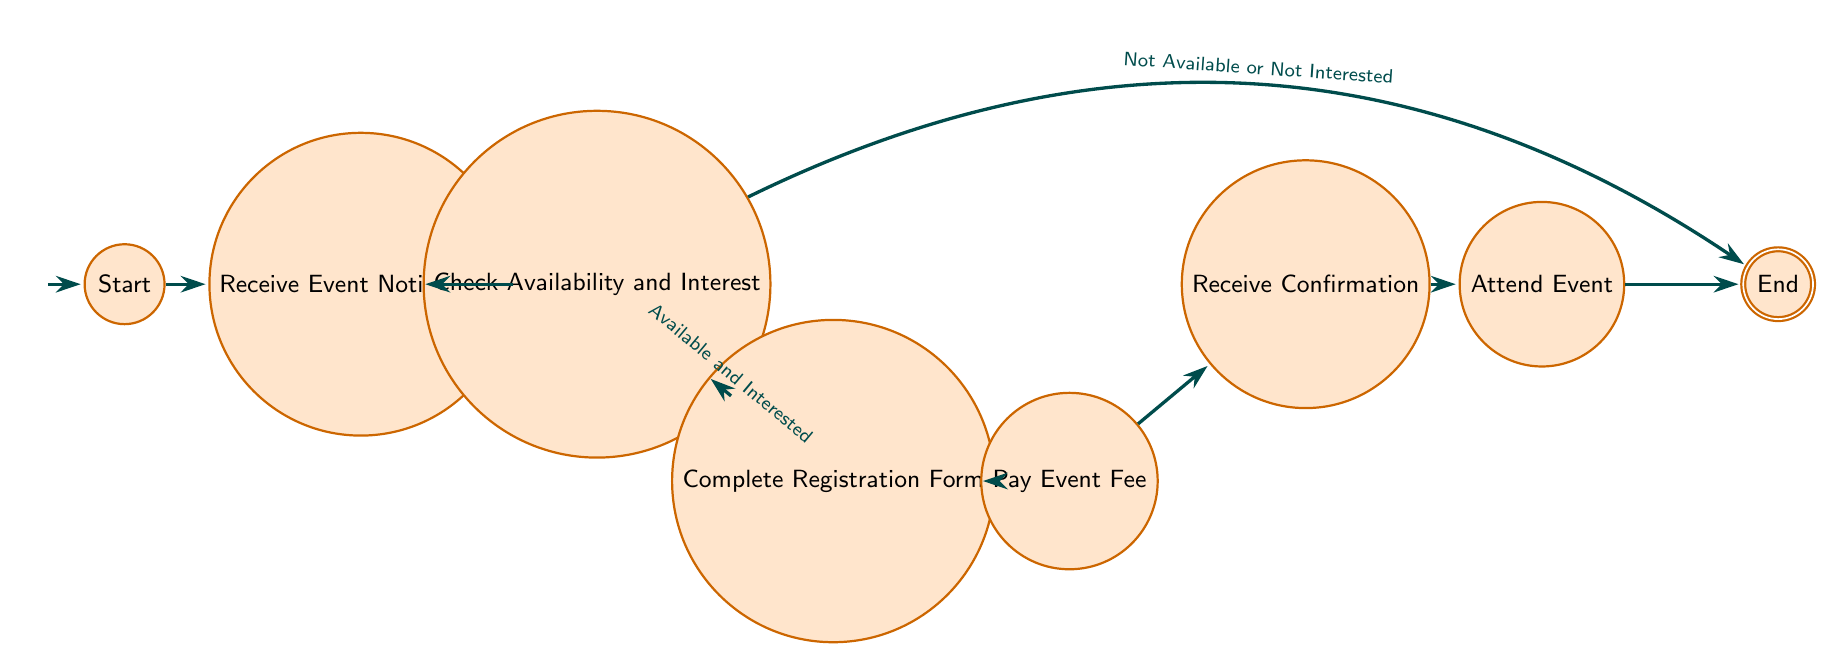What is the first step in the community event participation process? The diagram starts at the "Start" node, where the first action is to "Receive Event Notification." Thus, the first step is represented by this action.
Answer: Receive Event Notification How many nodes are there in total? Counting all represented actions and states, the nodes are: Start, Receive Event Notification, Check Availability and Interest, Complete Registration Form, Pay Event Fee, Receive Confirmation, Attend Event, and End. There are a total of 8 nodes.
Answer: 8 What happens if someone is not available or not interested? From the "Check Availability and Interest" node, if the person is not available or not interested, the flow goes directly to the "End" node, meaning they do not proceed further in the process.
Answer: End Which node comes after "Complete Registration Form"? The transition from "Complete Registration Form" leads directly to the "Pay Event Fee" node. Thus, after completing the registration form, the next step is to pay the fee.
Answer: Pay Event Fee How do you move from "Receive Confirmation" to "Attend Event"? The transition from "Receive Confirmation" to "Attend Event" is straightforward with no conditions; they are connected directly. After receiving confirmation, the participant simply moves to attend the event.
Answer: Attend Event What is the last action in the process? The last action is to "Attend Event." After completing this action, the process eventually leads to the "End" node. Therefore, the last action prior to completion is attending the event.
Answer: Attend Event Which node indicates the end of the participation process? The final node labeled "End" indicates the termination of the participation process in the diagram. This signifies that all steps have been completed.
Answer: End What condition must be met to continue to the registration form? The condition that must be met to move from "Check Availability and Interest" to "Complete Registration Form" is that the participant must be "Available and Interested." This requirement is essential to proceed.
Answer: Available and Interested 